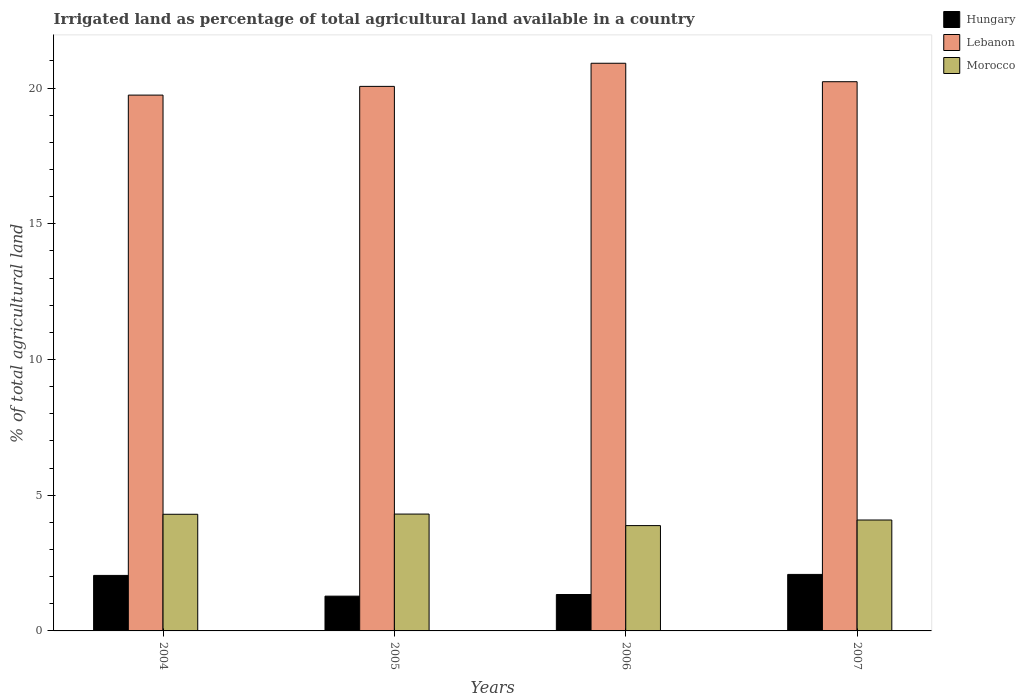How many groups of bars are there?
Offer a very short reply. 4. Are the number of bars per tick equal to the number of legend labels?
Your answer should be compact. Yes. Are the number of bars on each tick of the X-axis equal?
Give a very brief answer. Yes. How many bars are there on the 3rd tick from the left?
Your answer should be very brief. 3. How many bars are there on the 4th tick from the right?
Your answer should be very brief. 3. What is the percentage of irrigated land in Morocco in 2006?
Give a very brief answer. 3.88. Across all years, what is the maximum percentage of irrigated land in Hungary?
Give a very brief answer. 2.08. Across all years, what is the minimum percentage of irrigated land in Morocco?
Your answer should be compact. 3.88. In which year was the percentage of irrigated land in Morocco minimum?
Ensure brevity in your answer.  2006. What is the total percentage of irrigated land in Hungary in the graph?
Provide a short and direct response. 6.75. What is the difference between the percentage of irrigated land in Lebanon in 2004 and that in 2005?
Provide a succinct answer. -0.32. What is the difference between the percentage of irrigated land in Morocco in 2007 and the percentage of irrigated land in Lebanon in 2006?
Your answer should be compact. -16.83. What is the average percentage of irrigated land in Morocco per year?
Make the answer very short. 4.14. In the year 2006, what is the difference between the percentage of irrigated land in Lebanon and percentage of irrigated land in Morocco?
Your answer should be compact. 17.03. In how many years, is the percentage of irrigated land in Hungary greater than 10 %?
Provide a succinct answer. 0. What is the ratio of the percentage of irrigated land in Lebanon in 2004 to that in 2005?
Your answer should be compact. 0.98. Is the difference between the percentage of irrigated land in Lebanon in 2004 and 2007 greater than the difference between the percentage of irrigated land in Morocco in 2004 and 2007?
Give a very brief answer. No. What is the difference between the highest and the second highest percentage of irrigated land in Hungary?
Your response must be concise. 0.04. What is the difference between the highest and the lowest percentage of irrigated land in Lebanon?
Ensure brevity in your answer.  1.17. Is the sum of the percentage of irrigated land in Morocco in 2004 and 2006 greater than the maximum percentage of irrigated land in Hungary across all years?
Your answer should be very brief. Yes. What does the 1st bar from the left in 2005 represents?
Provide a short and direct response. Hungary. What does the 3rd bar from the right in 2004 represents?
Your answer should be very brief. Hungary. Is it the case that in every year, the sum of the percentage of irrigated land in Morocco and percentage of irrigated land in Hungary is greater than the percentage of irrigated land in Lebanon?
Provide a succinct answer. No. Are the values on the major ticks of Y-axis written in scientific E-notation?
Provide a succinct answer. No. Does the graph contain any zero values?
Your answer should be compact. No. Does the graph contain grids?
Offer a very short reply. No. Where does the legend appear in the graph?
Offer a terse response. Top right. How are the legend labels stacked?
Give a very brief answer. Vertical. What is the title of the graph?
Your response must be concise. Irrigated land as percentage of total agricultural land available in a country. What is the label or title of the Y-axis?
Offer a terse response. % of total agricultural land. What is the % of total agricultural land in Hungary in 2004?
Give a very brief answer. 2.05. What is the % of total agricultural land in Lebanon in 2004?
Your answer should be compact. 19.74. What is the % of total agricultural land in Morocco in 2004?
Offer a terse response. 4.3. What is the % of total agricultural land of Hungary in 2005?
Provide a short and direct response. 1.28. What is the % of total agricultural land of Lebanon in 2005?
Your answer should be very brief. 20.06. What is the % of total agricultural land in Morocco in 2005?
Provide a succinct answer. 4.3. What is the % of total agricultural land in Hungary in 2006?
Offer a terse response. 1.34. What is the % of total agricultural land in Lebanon in 2006?
Your answer should be compact. 20.91. What is the % of total agricultural land of Morocco in 2006?
Provide a succinct answer. 3.88. What is the % of total agricultural land of Hungary in 2007?
Offer a very short reply. 2.08. What is the % of total agricultural land in Lebanon in 2007?
Your answer should be very brief. 20.23. What is the % of total agricultural land of Morocco in 2007?
Your response must be concise. 4.09. Across all years, what is the maximum % of total agricultural land of Hungary?
Your response must be concise. 2.08. Across all years, what is the maximum % of total agricultural land in Lebanon?
Your answer should be compact. 20.91. Across all years, what is the maximum % of total agricultural land of Morocco?
Keep it short and to the point. 4.3. Across all years, what is the minimum % of total agricultural land in Hungary?
Give a very brief answer. 1.28. Across all years, what is the minimum % of total agricultural land in Lebanon?
Offer a very short reply. 19.74. Across all years, what is the minimum % of total agricultural land in Morocco?
Provide a short and direct response. 3.88. What is the total % of total agricultural land in Hungary in the graph?
Your answer should be compact. 6.75. What is the total % of total agricultural land of Lebanon in the graph?
Your response must be concise. 80.95. What is the total % of total agricultural land in Morocco in the graph?
Make the answer very short. 16.57. What is the difference between the % of total agricultural land in Hungary in 2004 and that in 2005?
Give a very brief answer. 0.76. What is the difference between the % of total agricultural land of Lebanon in 2004 and that in 2005?
Your answer should be compact. -0.32. What is the difference between the % of total agricultural land in Morocco in 2004 and that in 2005?
Keep it short and to the point. -0.01. What is the difference between the % of total agricultural land of Hungary in 2004 and that in 2006?
Keep it short and to the point. 0.7. What is the difference between the % of total agricultural land of Lebanon in 2004 and that in 2006?
Give a very brief answer. -1.17. What is the difference between the % of total agricultural land in Morocco in 2004 and that in 2006?
Your answer should be compact. 0.42. What is the difference between the % of total agricultural land in Hungary in 2004 and that in 2007?
Offer a very short reply. -0.04. What is the difference between the % of total agricultural land of Lebanon in 2004 and that in 2007?
Ensure brevity in your answer.  -0.49. What is the difference between the % of total agricultural land in Morocco in 2004 and that in 2007?
Make the answer very short. 0.21. What is the difference between the % of total agricultural land in Hungary in 2005 and that in 2006?
Make the answer very short. -0.06. What is the difference between the % of total agricultural land of Lebanon in 2005 and that in 2006?
Your answer should be very brief. -0.85. What is the difference between the % of total agricultural land in Morocco in 2005 and that in 2006?
Ensure brevity in your answer.  0.42. What is the difference between the % of total agricultural land of Hungary in 2005 and that in 2007?
Offer a very short reply. -0.8. What is the difference between the % of total agricultural land in Lebanon in 2005 and that in 2007?
Give a very brief answer. -0.17. What is the difference between the % of total agricultural land of Morocco in 2005 and that in 2007?
Ensure brevity in your answer.  0.22. What is the difference between the % of total agricultural land in Hungary in 2006 and that in 2007?
Offer a terse response. -0.74. What is the difference between the % of total agricultural land of Lebanon in 2006 and that in 2007?
Provide a succinct answer. 0.68. What is the difference between the % of total agricultural land in Morocco in 2006 and that in 2007?
Your answer should be very brief. -0.21. What is the difference between the % of total agricultural land in Hungary in 2004 and the % of total agricultural land in Lebanon in 2005?
Offer a very short reply. -18.02. What is the difference between the % of total agricultural land in Hungary in 2004 and the % of total agricultural land in Morocco in 2005?
Provide a short and direct response. -2.26. What is the difference between the % of total agricultural land of Lebanon in 2004 and the % of total agricultural land of Morocco in 2005?
Offer a very short reply. 15.44. What is the difference between the % of total agricultural land in Hungary in 2004 and the % of total agricultural land in Lebanon in 2006?
Offer a terse response. -18.87. What is the difference between the % of total agricultural land of Hungary in 2004 and the % of total agricultural land of Morocco in 2006?
Make the answer very short. -1.83. What is the difference between the % of total agricultural land in Lebanon in 2004 and the % of total agricultural land in Morocco in 2006?
Give a very brief answer. 15.86. What is the difference between the % of total agricultural land of Hungary in 2004 and the % of total agricultural land of Lebanon in 2007?
Give a very brief answer. -18.19. What is the difference between the % of total agricultural land of Hungary in 2004 and the % of total agricultural land of Morocco in 2007?
Your answer should be compact. -2.04. What is the difference between the % of total agricultural land in Lebanon in 2004 and the % of total agricultural land in Morocco in 2007?
Provide a succinct answer. 15.65. What is the difference between the % of total agricultural land in Hungary in 2005 and the % of total agricultural land in Lebanon in 2006?
Offer a terse response. -19.63. What is the difference between the % of total agricultural land of Hungary in 2005 and the % of total agricultural land of Morocco in 2006?
Keep it short and to the point. -2.6. What is the difference between the % of total agricultural land of Lebanon in 2005 and the % of total agricultural land of Morocco in 2006?
Your response must be concise. 16.18. What is the difference between the % of total agricultural land of Hungary in 2005 and the % of total agricultural land of Lebanon in 2007?
Give a very brief answer. -18.95. What is the difference between the % of total agricultural land of Hungary in 2005 and the % of total agricultural land of Morocco in 2007?
Your response must be concise. -2.81. What is the difference between the % of total agricultural land of Lebanon in 2005 and the % of total agricultural land of Morocco in 2007?
Give a very brief answer. 15.98. What is the difference between the % of total agricultural land in Hungary in 2006 and the % of total agricultural land in Lebanon in 2007?
Your answer should be compact. -18.89. What is the difference between the % of total agricultural land of Hungary in 2006 and the % of total agricultural land of Morocco in 2007?
Your answer should be very brief. -2.74. What is the difference between the % of total agricultural land in Lebanon in 2006 and the % of total agricultural land in Morocco in 2007?
Provide a short and direct response. 16.83. What is the average % of total agricultural land of Hungary per year?
Provide a succinct answer. 1.69. What is the average % of total agricultural land of Lebanon per year?
Provide a succinct answer. 20.24. What is the average % of total agricultural land of Morocco per year?
Make the answer very short. 4.14. In the year 2004, what is the difference between the % of total agricultural land of Hungary and % of total agricultural land of Lebanon?
Your answer should be compact. -17.69. In the year 2004, what is the difference between the % of total agricultural land of Hungary and % of total agricultural land of Morocco?
Provide a succinct answer. -2.25. In the year 2004, what is the difference between the % of total agricultural land in Lebanon and % of total agricultural land in Morocco?
Make the answer very short. 15.44. In the year 2005, what is the difference between the % of total agricultural land of Hungary and % of total agricultural land of Lebanon?
Your answer should be very brief. -18.78. In the year 2005, what is the difference between the % of total agricultural land of Hungary and % of total agricultural land of Morocco?
Ensure brevity in your answer.  -3.02. In the year 2005, what is the difference between the % of total agricultural land of Lebanon and % of total agricultural land of Morocco?
Make the answer very short. 15.76. In the year 2006, what is the difference between the % of total agricultural land in Hungary and % of total agricultural land in Lebanon?
Provide a succinct answer. -19.57. In the year 2006, what is the difference between the % of total agricultural land of Hungary and % of total agricultural land of Morocco?
Your answer should be compact. -2.54. In the year 2006, what is the difference between the % of total agricultural land of Lebanon and % of total agricultural land of Morocco?
Offer a very short reply. 17.03. In the year 2007, what is the difference between the % of total agricultural land in Hungary and % of total agricultural land in Lebanon?
Your answer should be very brief. -18.15. In the year 2007, what is the difference between the % of total agricultural land of Hungary and % of total agricultural land of Morocco?
Offer a very short reply. -2. In the year 2007, what is the difference between the % of total agricultural land in Lebanon and % of total agricultural land in Morocco?
Your response must be concise. 16.15. What is the ratio of the % of total agricultural land in Hungary in 2004 to that in 2005?
Make the answer very short. 1.6. What is the ratio of the % of total agricultural land in Lebanon in 2004 to that in 2005?
Give a very brief answer. 0.98. What is the ratio of the % of total agricultural land in Hungary in 2004 to that in 2006?
Offer a very short reply. 1.52. What is the ratio of the % of total agricultural land in Lebanon in 2004 to that in 2006?
Give a very brief answer. 0.94. What is the ratio of the % of total agricultural land of Morocco in 2004 to that in 2006?
Offer a very short reply. 1.11. What is the ratio of the % of total agricultural land of Hungary in 2004 to that in 2007?
Your response must be concise. 0.98. What is the ratio of the % of total agricultural land of Lebanon in 2004 to that in 2007?
Keep it short and to the point. 0.98. What is the ratio of the % of total agricultural land in Morocco in 2004 to that in 2007?
Keep it short and to the point. 1.05. What is the ratio of the % of total agricultural land in Hungary in 2005 to that in 2006?
Your response must be concise. 0.95. What is the ratio of the % of total agricultural land in Lebanon in 2005 to that in 2006?
Your answer should be very brief. 0.96. What is the ratio of the % of total agricultural land in Morocco in 2005 to that in 2006?
Your answer should be very brief. 1.11. What is the ratio of the % of total agricultural land in Hungary in 2005 to that in 2007?
Offer a very short reply. 0.62. What is the ratio of the % of total agricultural land of Morocco in 2005 to that in 2007?
Ensure brevity in your answer.  1.05. What is the ratio of the % of total agricultural land in Hungary in 2006 to that in 2007?
Keep it short and to the point. 0.64. What is the ratio of the % of total agricultural land in Lebanon in 2006 to that in 2007?
Provide a short and direct response. 1.03. What is the ratio of the % of total agricultural land of Morocco in 2006 to that in 2007?
Your answer should be compact. 0.95. What is the difference between the highest and the second highest % of total agricultural land in Hungary?
Offer a very short reply. 0.04. What is the difference between the highest and the second highest % of total agricultural land of Lebanon?
Provide a succinct answer. 0.68. What is the difference between the highest and the second highest % of total agricultural land in Morocco?
Your answer should be very brief. 0.01. What is the difference between the highest and the lowest % of total agricultural land of Hungary?
Your answer should be compact. 0.8. What is the difference between the highest and the lowest % of total agricultural land of Lebanon?
Give a very brief answer. 1.17. What is the difference between the highest and the lowest % of total agricultural land in Morocco?
Make the answer very short. 0.42. 